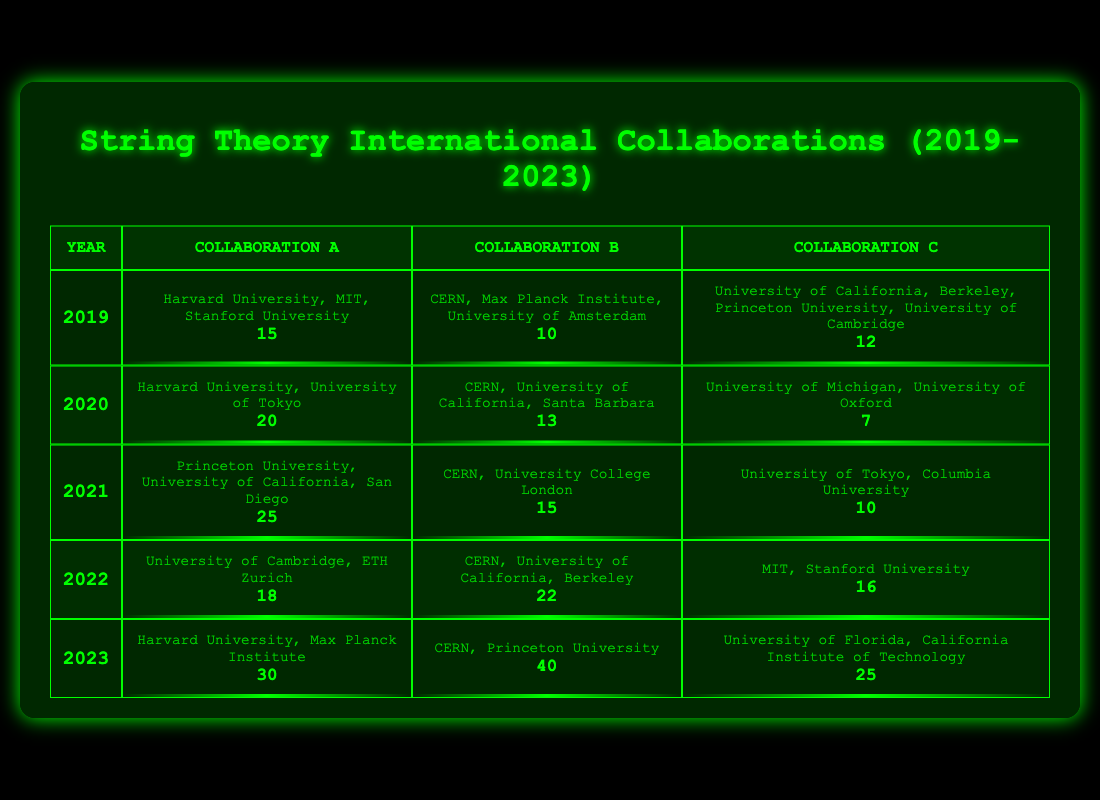What was the highest collaboration count for collaboration B in any year? Looking at the table, the collaboration counts for collaboration B are: 10 (2019), 13 (2020), 15 (2021), 22 (2022), and 40 (2023). The highest value is 40 in 2023.
Answer: 40 Which collaboration had the least count in 2020? The collaboration counts in 2020 are 20 (collaboration A), 13 (collaboration B), and 7 (collaboration C). The least count is 7, which belongs to collaboration C.
Answer: collaboration C What was the total number of collaborations for all years in 2021? The collaboration counts in 2021 are: 25 (collaboration A), 15 (collaboration B), and 10 (collaboration C). The total is calculated as 25 + 15 + 10 = 50.
Answer: 50 Did collaboration A's count increase every year from 2019 to 2023? Collaboration A's counts over the years are: 15 (2019), 20 (2020), 25 (2021), 18 (2022), and 30 (2023). Notably, it decreased from 25 to 18 between 2021 and 2022, indicating that it did not increase every year.
Answer: No What is the average collaboration count for collaboration C over the years provided? The counts for collaboration C by year are: 12 (2019), 7 (2020), 10 (2021), 16 (2022), and 25 (2023). The sum of these counts is 12 + 7 + 10 + 16 + 25 = 70. There are 5 data points, so the average is 70/5 = 14.
Answer: 14 What was the total number of collaborations for all collaborations in 2022? The counts in 2022 are: 18 (collaboration A), 22 (collaboration B), and 16 (collaboration C). Summing these gives 18 + 22 + 16 = 56.
Answer: 56 In which year did collaboration A have the maximum count? Collaboration A's counts are as follows: 15 (2019), 20 (2020), 25 (2021), 18 (2022), and 30 (2023). The maximum count of 30 occurred in 2023.
Answer: 2023 How many collaborations were there in total across all collaborations in 2020? For 2020, the counts are: 20 (collaboration A), 13 (collaboration B), and 7 (collaboration C). Adding them gives 20 + 13 + 7 = 40.
Answer: 40 